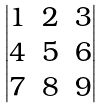<formula> <loc_0><loc_0><loc_500><loc_500>\begin{vmatrix} 1 & 2 & 3 \\ 4 & 5 & 6 \\ 7 & 8 & 9 \end{vmatrix}</formula> 